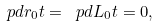<formula> <loc_0><loc_0><loc_500><loc_500>\ p d { r _ { 0 } } { t } = \ p d { L _ { 0 } } { t } = 0 ,</formula> 